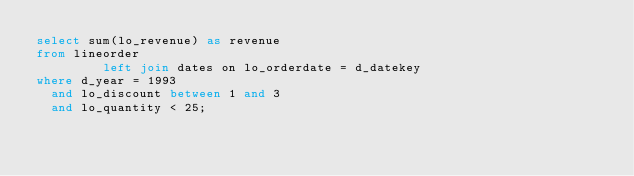<code> <loc_0><loc_0><loc_500><loc_500><_SQL_>select sum(lo_revenue) as revenue
from lineorder
         left join dates on lo_orderdate = d_datekey
where d_year = 1993
  and lo_discount between 1 and 3
  and lo_quantity < 25;

</code> 